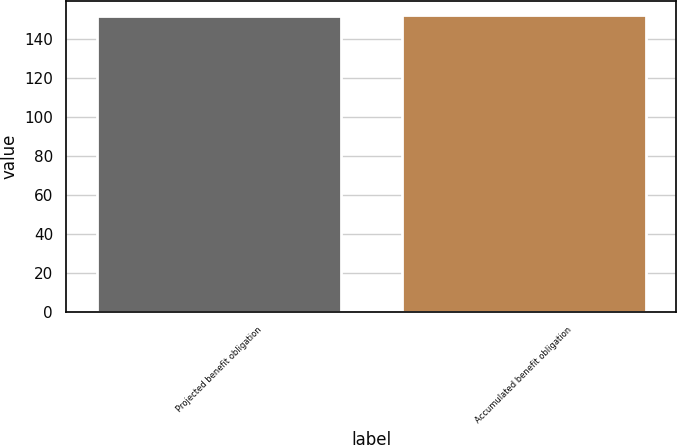Convert chart to OTSL. <chart><loc_0><loc_0><loc_500><loc_500><bar_chart><fcel>Projected benefit obligation<fcel>Accumulated benefit obligation<nl><fcel>152<fcel>152.1<nl></chart> 